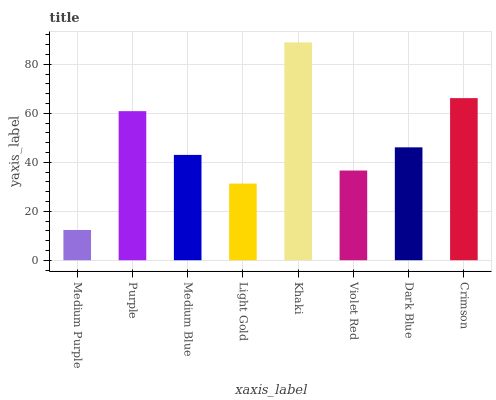Is Medium Purple the minimum?
Answer yes or no. Yes. Is Khaki the maximum?
Answer yes or no. Yes. Is Purple the minimum?
Answer yes or no. No. Is Purple the maximum?
Answer yes or no. No. Is Purple greater than Medium Purple?
Answer yes or no. Yes. Is Medium Purple less than Purple?
Answer yes or no. Yes. Is Medium Purple greater than Purple?
Answer yes or no. No. Is Purple less than Medium Purple?
Answer yes or no. No. Is Dark Blue the high median?
Answer yes or no. Yes. Is Medium Blue the low median?
Answer yes or no. Yes. Is Violet Red the high median?
Answer yes or no. No. Is Dark Blue the low median?
Answer yes or no. No. 